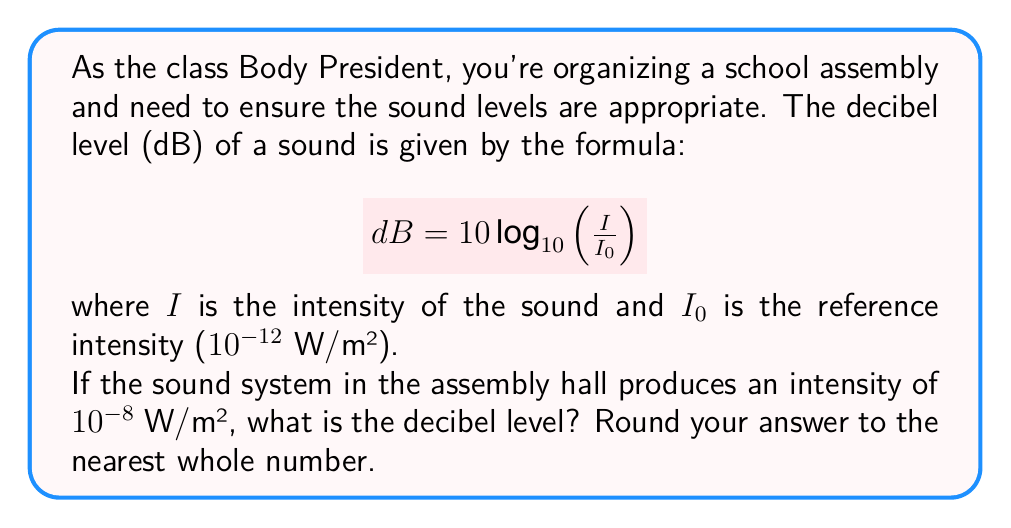What is the answer to this math problem? Let's approach this step-by-step:

1) We're given the formula: $$ dB = 10 \log_{10}\left(\frac{I}{I_0}\right) $$

2) We know:
   $I = 10^{-8}$ W/m²
   $I_0 = 10^{-12}$ W/m²

3) Let's substitute these values into the formula:

   $$ dB = 10 \log_{10}\left(\frac{10^{-8}}{10^{-12}}\right) $$

4) Simplify inside the parentheses:

   $$ dB = 10 \log_{10}(10^4) $$

5) Use the logarithm property $\log_a(x^n) = n\log_a(x)$:

   $$ dB = 10 \cdot 4 \log_{10}(10) $$

6) We know that $\log_{10}(10) = 1$, so:

   $$ dB = 10 \cdot 4 \cdot 1 = 40 $$

Therefore, the decibel level is 40 dB.
Answer: 40 dB 